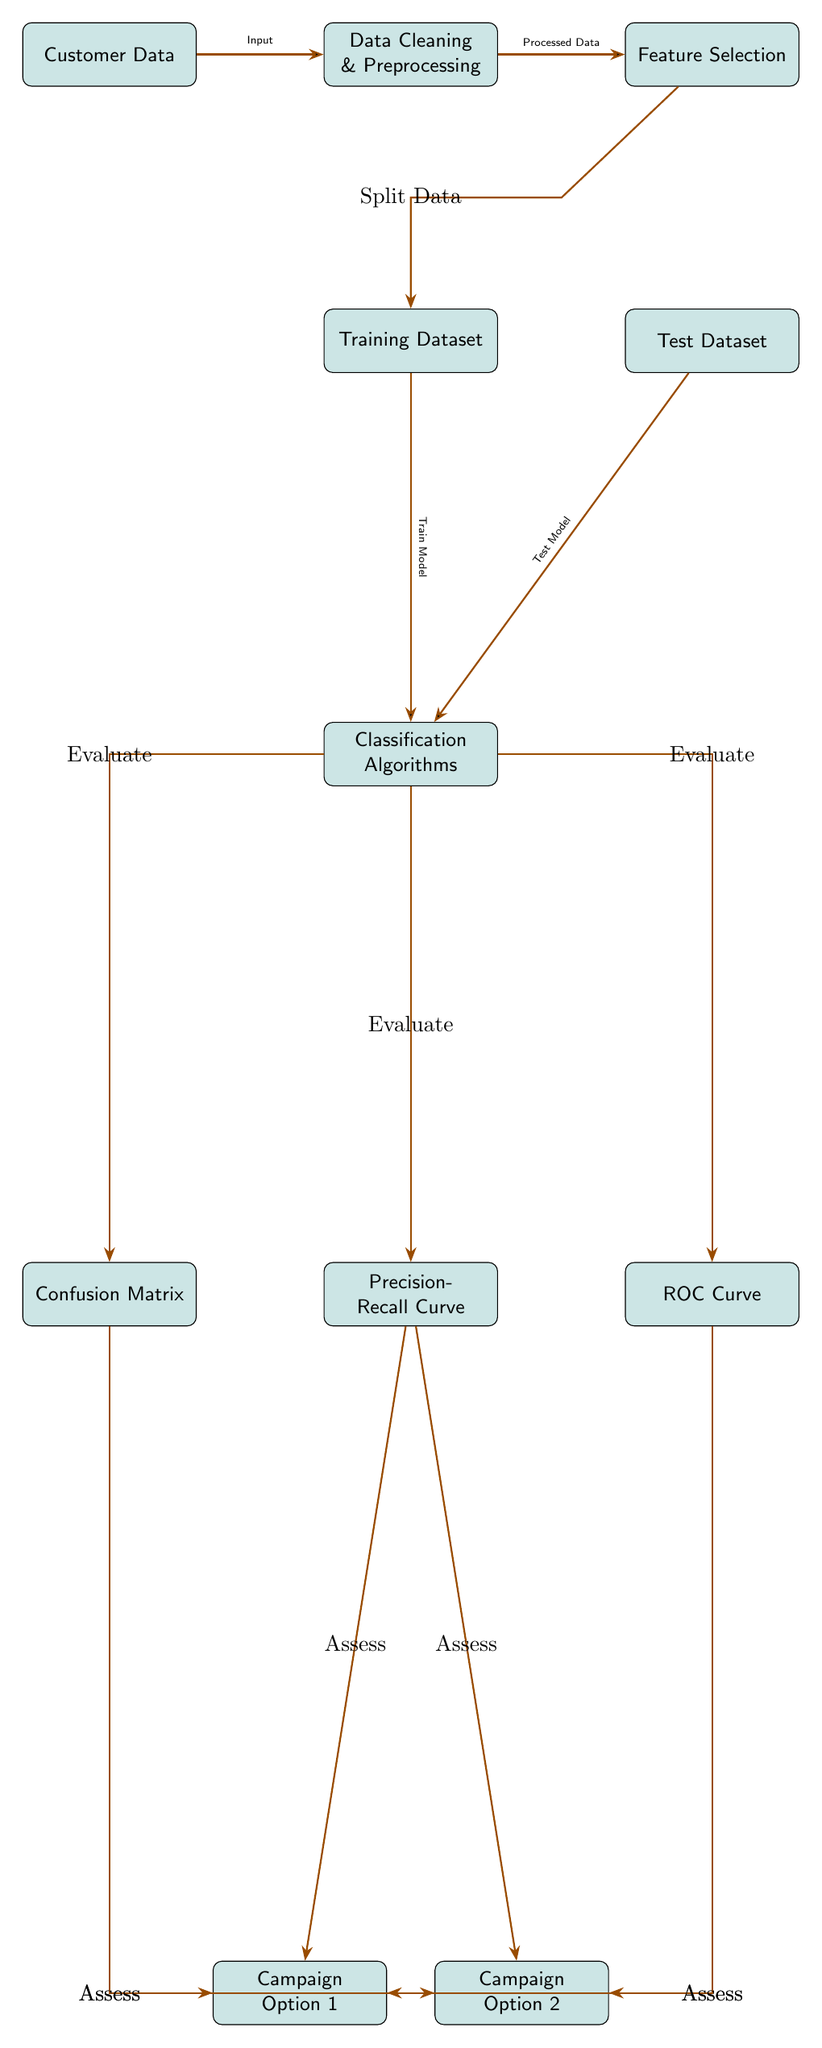What is the first node in the diagram? The first node represents "Customer Data," which is the initial input for the process.
Answer: Customer Data How many classification algorithms are indicated in the diagram? The diagram shows one node labeled "Classification Algorithms," indicating a single step towards model evaluation.
Answer: 1 What is the output from the "Data Cleaning & Preprocessing" node? The arrow indicating the flow from "Data Cleaning & Preprocessing" leads to the "Feature Selection" node, meaning the processed data from cleaning is utilized for feature selection.
Answer: Processed Data Which options are evaluated using precision-recall curves? The precision-recall curves evaluate the success of Campaign Option 1 and Campaign Option 2 as indicated by the connections from that node.
Answer: Campaign Option 1 and Campaign Option 2 What do you assess from the confusion matrix? The confusion matrix assesses the performance measures of both Campaign Option 1 and Campaign Option 2 as shown by the branching arrows that lead to each campaign option.
Answer: Campaign Option 1 and Campaign Option 2 Which two datasets are created from the feature selection process? "Training Dataset" and "Test Dataset" are the two datasets produced after the data has undergone feature selection.
Answer: Training Dataset and Test Dataset What connects the "Test Dataset" to classification algorithms? The diagram indicates that the "Test Dataset" flows into the "Classification Algorithms" node to facilitate the testing of the model.
Answer: Test Model Which node directly follows the "Training Dataset" in the diagram? The node that directly follows the "Training Dataset" is the "Classification Algorithms," as indicated by the flow of the diagram.
Answer: Classification Algorithms Where do the output nodes for assessing campaign options originate from? The output nodes for assessing campaign options originate from "Precision-Recall Curve," as indicated by the connecting arrows from that node.
Answer: Precision-Recall Curve 